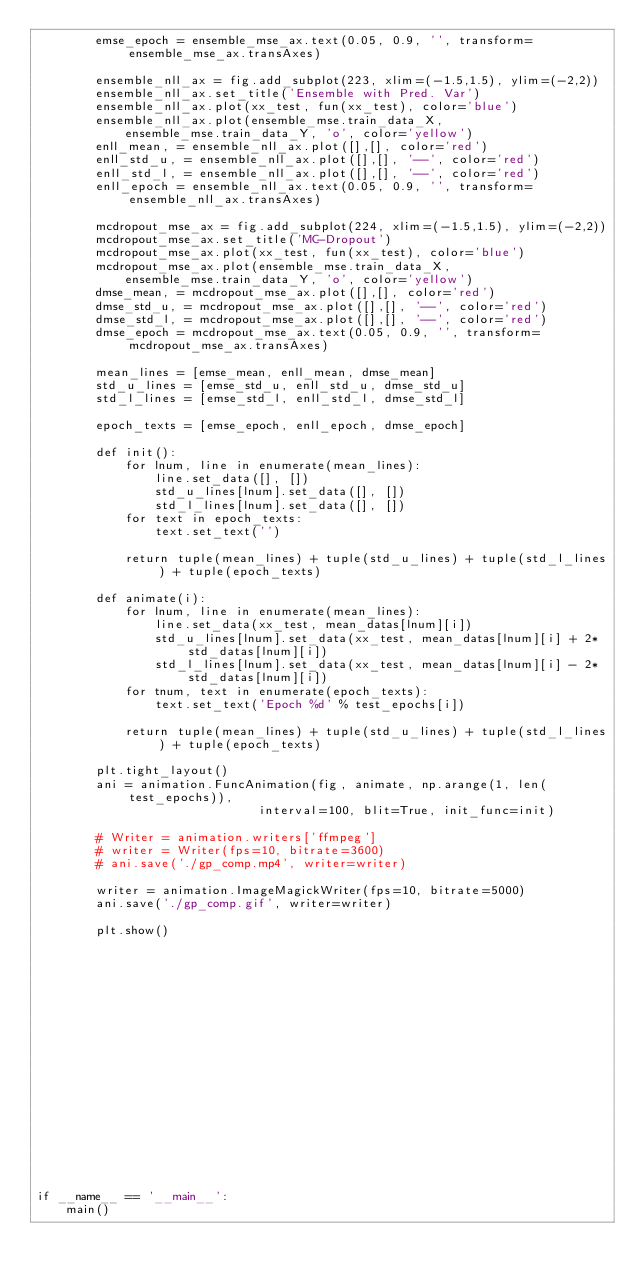<code> <loc_0><loc_0><loc_500><loc_500><_Python_>        emse_epoch = ensemble_mse_ax.text(0.05, 0.9, '', transform=ensemble_mse_ax.transAxes)

        ensemble_nll_ax = fig.add_subplot(223, xlim=(-1.5,1.5), ylim=(-2,2))
        ensemble_nll_ax.set_title('Ensemble with Pred. Var')
        ensemble_nll_ax.plot(xx_test, fun(xx_test), color='blue')
        ensemble_nll_ax.plot(ensemble_mse.train_data_X, 
            ensemble_mse.train_data_Y, 'o', color='yellow')
        enll_mean, = ensemble_nll_ax.plot([],[], color='red')
        enll_std_u, = ensemble_nll_ax.plot([],[], '--', color='red')
        enll_std_l, = ensemble_nll_ax.plot([],[], '--', color='red')
        enll_epoch = ensemble_nll_ax.text(0.05, 0.9, '', transform=ensemble_nll_ax.transAxes)

        mcdropout_mse_ax = fig.add_subplot(224, xlim=(-1.5,1.5), ylim=(-2,2))
        mcdropout_mse_ax.set_title('MC-Dropout')
        mcdropout_mse_ax.plot(xx_test, fun(xx_test), color='blue')
        mcdropout_mse_ax.plot(ensemble_mse.train_data_X, 
            ensemble_mse.train_data_Y, 'o', color='yellow')
        dmse_mean, = mcdropout_mse_ax.plot([],[], color='red')
        dmse_std_u, = mcdropout_mse_ax.plot([],[], '--', color='red')
        dmse_std_l, = mcdropout_mse_ax.plot([],[], '--', color='red')
        dmse_epoch = mcdropout_mse_ax.text(0.05, 0.9, '', transform=mcdropout_mse_ax.transAxes)

        mean_lines = [emse_mean, enll_mean, dmse_mean]
        std_u_lines = [emse_std_u, enll_std_u, dmse_std_u]
        std_l_lines = [emse_std_l, enll_std_l, dmse_std_l]

        epoch_texts = [emse_epoch, enll_epoch, dmse_epoch]

        def init():
            for lnum, line in enumerate(mean_lines):
                line.set_data([], [])
                std_u_lines[lnum].set_data([], [])
                std_l_lines[lnum].set_data([], [])
            for text in epoch_texts:
                text.set_text('')

            return tuple(mean_lines) + tuple(std_u_lines) + tuple(std_l_lines) + tuple(epoch_texts)

        def animate(i):
            for lnum, line in enumerate(mean_lines):
                line.set_data(xx_test, mean_datas[lnum][i])
                std_u_lines[lnum].set_data(xx_test, mean_datas[lnum][i] + 2*std_datas[lnum][i])
                std_l_lines[lnum].set_data(xx_test, mean_datas[lnum][i] - 2*std_datas[lnum][i])
            for tnum, text in enumerate(epoch_texts):
                text.set_text('Epoch %d' % test_epochs[i])

            return tuple(mean_lines) + tuple(std_u_lines) + tuple(std_l_lines) + tuple(epoch_texts)

        plt.tight_layout()
        ani = animation.FuncAnimation(fig, animate, np.arange(1, len(test_epochs)),
                              interval=100, blit=True, init_func=init)

        # Writer = animation.writers['ffmpeg']
        # writer = Writer(fps=10, bitrate=3600)
        # ani.save('./gp_comp.mp4', writer=writer)

        writer = animation.ImageMagickWriter(fps=10, bitrate=5000)
        ani.save('./gp_comp.gif', writer=writer)

        plt.show()



















if __name__ == '__main__':
    main()

</code> 